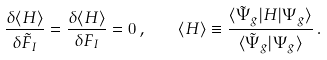<formula> <loc_0><loc_0><loc_500><loc_500>\frac { \delta \langle H \rangle } { \delta \tilde { F } _ { I } } = \frac { \delta \langle H \rangle } { \delta F _ { I } } = 0 \, , \quad \langle H \rangle \equiv \frac { \langle \tilde { \Psi } _ { g } | H | \Psi _ { g } \rangle } { \langle \tilde { \Psi } _ { g } | \Psi _ { g } \rangle } \, .</formula> 